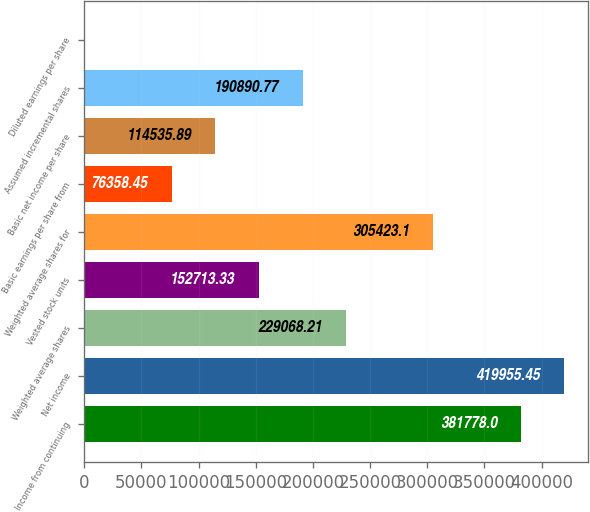Convert chart. <chart><loc_0><loc_0><loc_500><loc_500><bar_chart><fcel>Income from continuing<fcel>Net income<fcel>Weighted average shares<fcel>Vested stock units<fcel>Weighted average shares for<fcel>Basic earnings per share from<fcel>Basic net income per share<fcel>Assumed incremental shares<fcel>Diluted earnings per share<nl><fcel>381778<fcel>419955<fcel>229068<fcel>152713<fcel>305423<fcel>76358.4<fcel>114536<fcel>190891<fcel>3.55<nl></chart> 